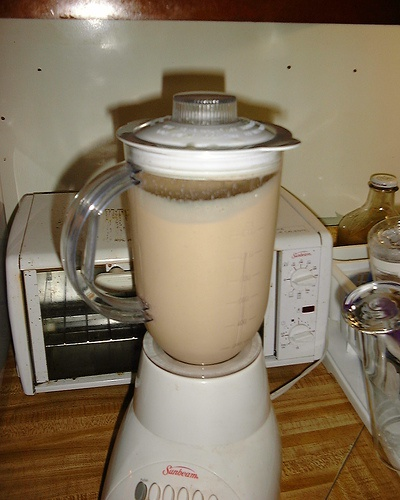Describe the objects in this image and their specific colors. I can see cup in black, gray, and maroon tones, bottle in black, olive, and maroon tones, and cup in black, gray, olive, and darkgray tones in this image. 